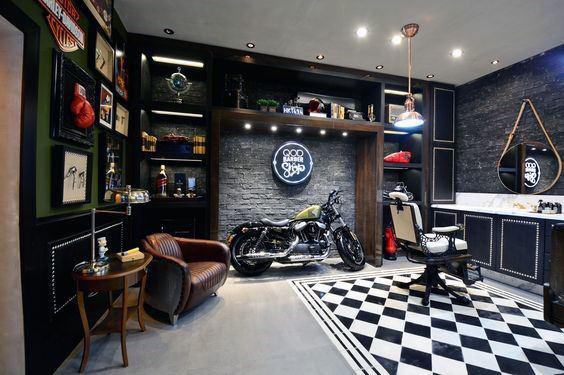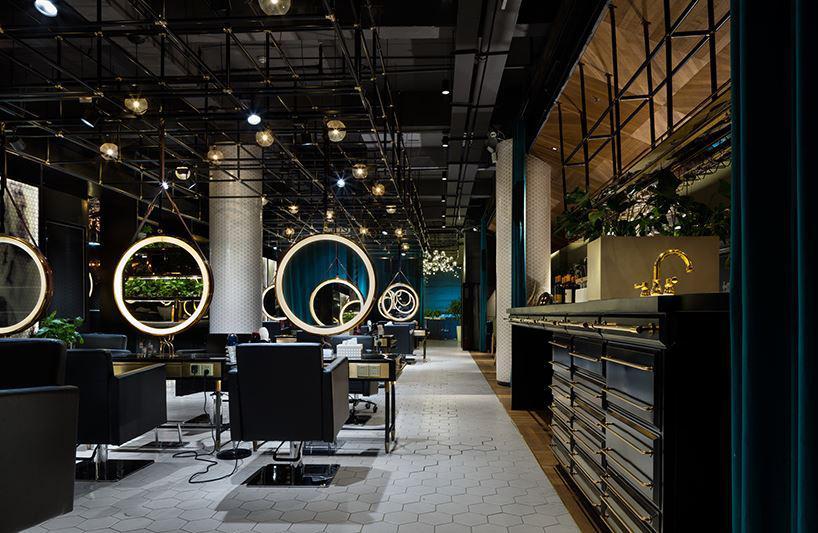The first image is the image on the left, the second image is the image on the right. For the images shown, is this caption "In at least one image there is a row of three white circles over a glass nail tables." true? Answer yes or no. Yes. The first image is the image on the left, the second image is the image on the right. Examine the images to the left and right. Is the description "Round mirrors in white frames are suspended in front of dark armchairs from black metal bars, in one image." accurate? Answer yes or no. Yes. 